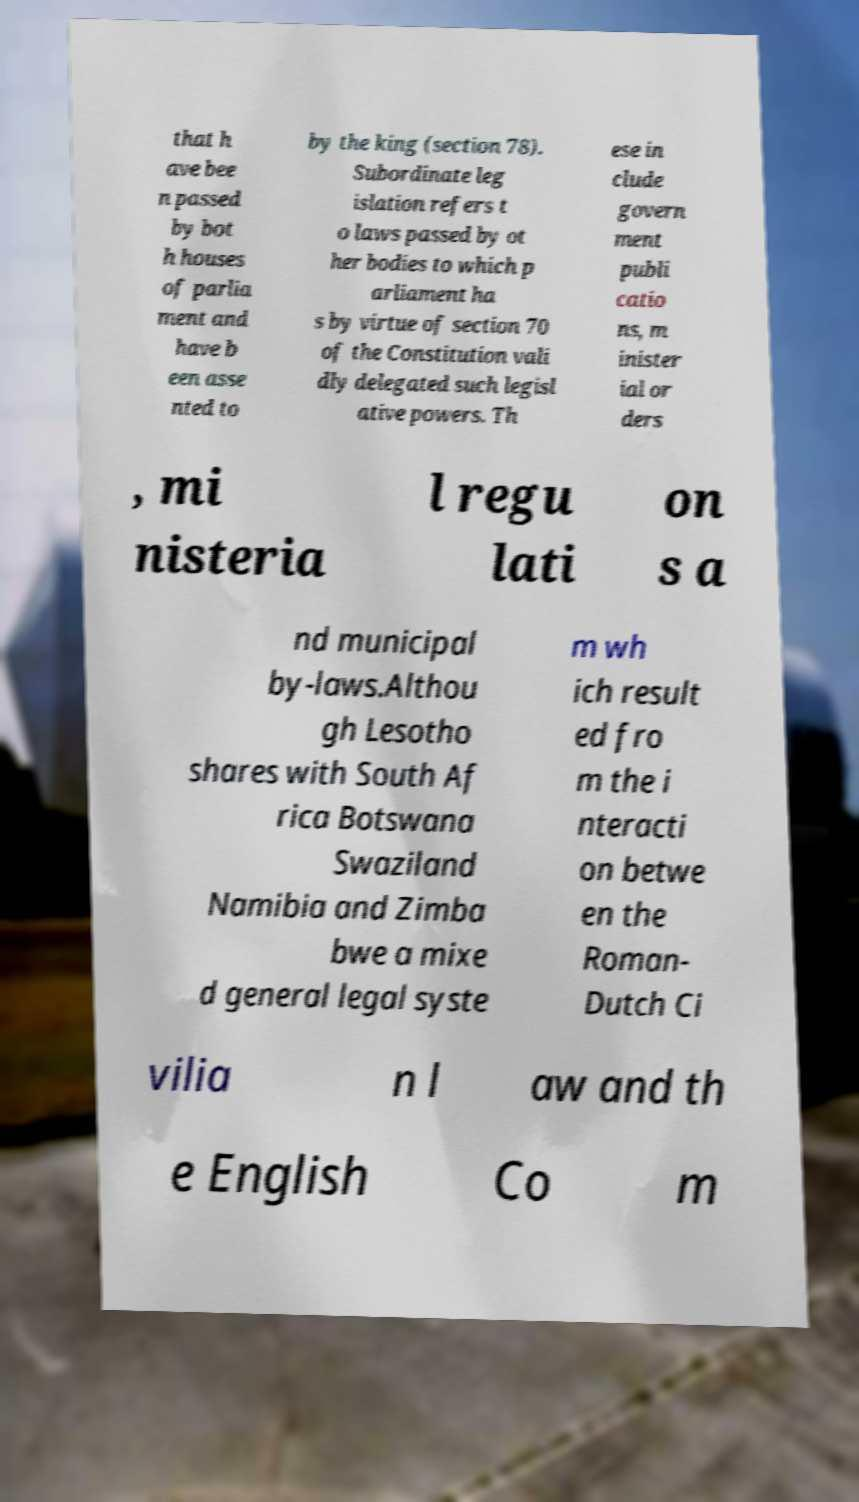Could you extract and type out the text from this image? that h ave bee n passed by bot h houses of parlia ment and have b een asse nted to by the king (section 78). Subordinate leg islation refers t o laws passed by ot her bodies to which p arliament ha s by virtue of section 70 of the Constitution vali dly delegated such legisl ative powers. Th ese in clude govern ment publi catio ns, m inister ial or ders , mi nisteria l regu lati on s a nd municipal by-laws.Althou gh Lesotho shares with South Af rica Botswana Swaziland Namibia and Zimba bwe a mixe d general legal syste m wh ich result ed fro m the i nteracti on betwe en the Roman- Dutch Ci vilia n l aw and th e English Co m 